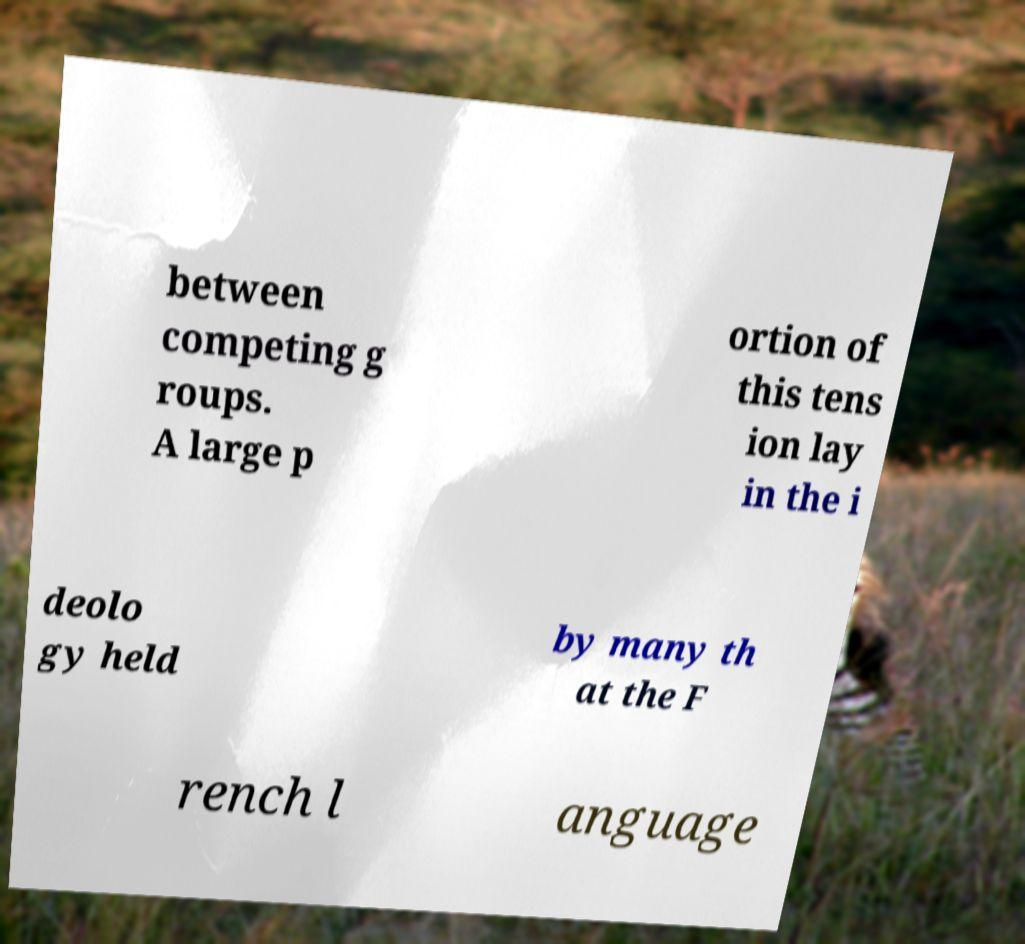There's text embedded in this image that I need extracted. Can you transcribe it verbatim? between competing g roups. A large p ortion of this tens ion lay in the i deolo gy held by many th at the F rench l anguage 